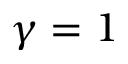<formula> <loc_0><loc_0><loc_500><loc_500>\gamma = 1</formula> 